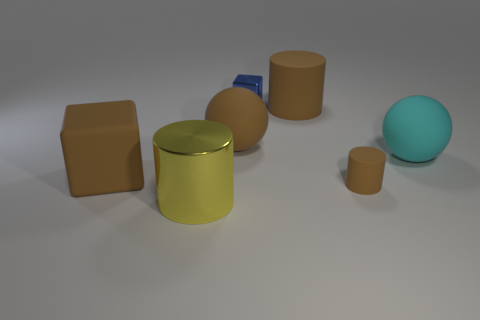Could you describe the lighting and shadows in the scene? Certainly. The scene is lit from above, creating soft shadows directly beneath and to the sides of the objects. The differing intensity and direction of the shadows suggest a single, diffused light source. The shadows are soft-edged, which contributes to the calm and balanced ambiance of the scene. 